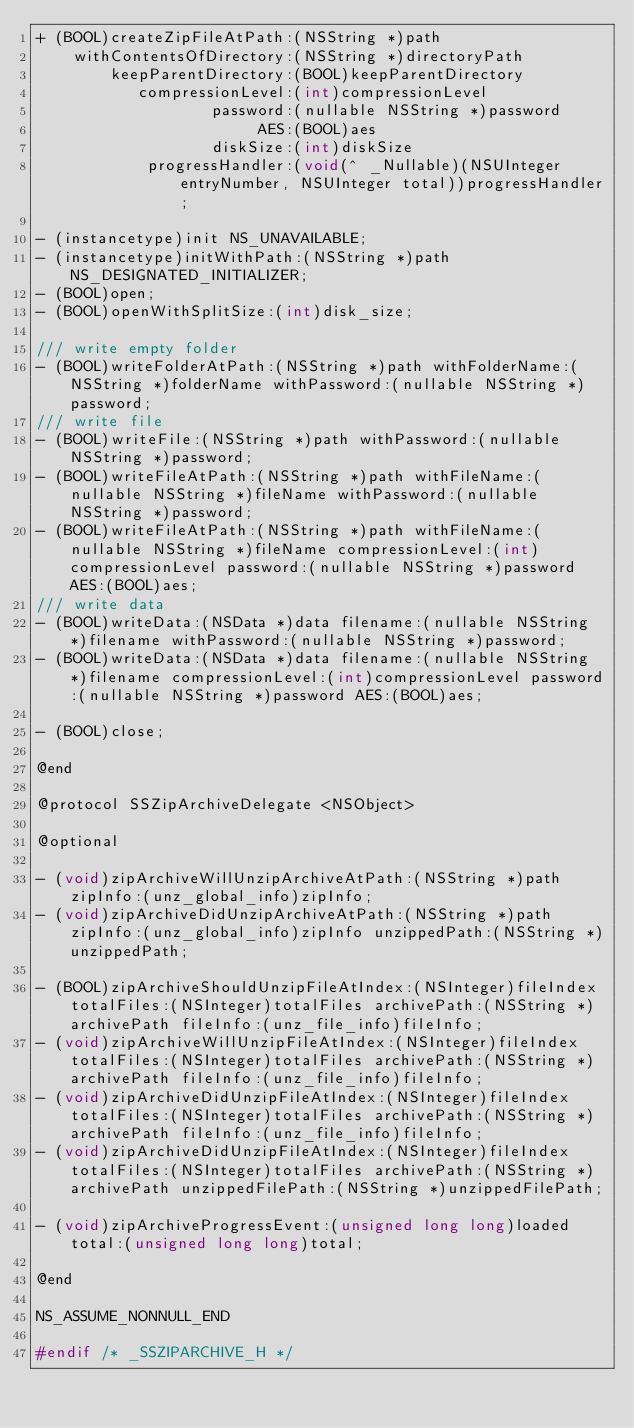Convert code to text. <code><loc_0><loc_0><loc_500><loc_500><_C_>+ (BOOL)createZipFileAtPath:(NSString *)path
    withContentsOfDirectory:(NSString *)directoryPath
        keepParentDirectory:(BOOL)keepParentDirectory
           compressionLevel:(int)compressionLevel
                   password:(nullable NSString *)password
                        AES:(BOOL)aes
                   diskSize:(int)diskSize
            progressHandler:(void(^ _Nullable)(NSUInteger entryNumber, NSUInteger total))progressHandler;

- (instancetype)init NS_UNAVAILABLE;
- (instancetype)initWithPath:(NSString *)path NS_DESIGNATED_INITIALIZER;
- (BOOL)open;
- (BOOL)openWithSplitSize:(int)disk_size;

/// write empty folder
- (BOOL)writeFolderAtPath:(NSString *)path withFolderName:(NSString *)folderName withPassword:(nullable NSString *)password;
/// write file
- (BOOL)writeFile:(NSString *)path withPassword:(nullable NSString *)password;
- (BOOL)writeFileAtPath:(NSString *)path withFileName:(nullable NSString *)fileName withPassword:(nullable NSString *)password;
- (BOOL)writeFileAtPath:(NSString *)path withFileName:(nullable NSString *)fileName compressionLevel:(int)compressionLevel password:(nullable NSString *)password AES:(BOOL)aes;
/// write data
- (BOOL)writeData:(NSData *)data filename:(nullable NSString *)filename withPassword:(nullable NSString *)password;
- (BOOL)writeData:(NSData *)data filename:(nullable NSString *)filename compressionLevel:(int)compressionLevel password:(nullable NSString *)password AES:(BOOL)aes;

- (BOOL)close;

@end

@protocol SSZipArchiveDelegate <NSObject>

@optional

- (void)zipArchiveWillUnzipArchiveAtPath:(NSString *)path zipInfo:(unz_global_info)zipInfo;
- (void)zipArchiveDidUnzipArchiveAtPath:(NSString *)path zipInfo:(unz_global_info)zipInfo unzippedPath:(NSString *)unzippedPath;

- (BOOL)zipArchiveShouldUnzipFileAtIndex:(NSInteger)fileIndex totalFiles:(NSInteger)totalFiles archivePath:(NSString *)archivePath fileInfo:(unz_file_info)fileInfo;
- (void)zipArchiveWillUnzipFileAtIndex:(NSInteger)fileIndex totalFiles:(NSInteger)totalFiles archivePath:(NSString *)archivePath fileInfo:(unz_file_info)fileInfo;
- (void)zipArchiveDidUnzipFileAtIndex:(NSInteger)fileIndex totalFiles:(NSInteger)totalFiles archivePath:(NSString *)archivePath fileInfo:(unz_file_info)fileInfo;
- (void)zipArchiveDidUnzipFileAtIndex:(NSInteger)fileIndex totalFiles:(NSInteger)totalFiles archivePath:(NSString *)archivePath unzippedFilePath:(NSString *)unzippedFilePath;

- (void)zipArchiveProgressEvent:(unsigned long long)loaded total:(unsigned long long)total;

@end

NS_ASSUME_NONNULL_END

#endif /* _SSZIPARCHIVE_H */
</code> 